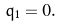<formula> <loc_0><loc_0><loc_500><loc_500>q _ { 1 } = 0 .</formula> 